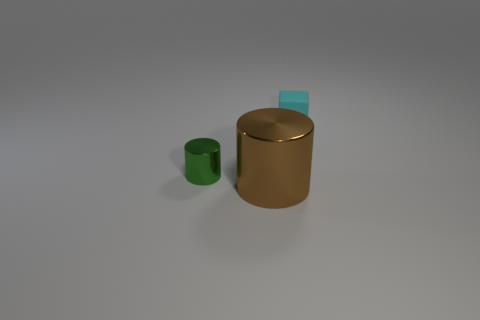Are there any small green things that have the same material as the big brown cylinder?
Keep it short and to the point. Yes. Are there any other things that have the same material as the tiny cyan cube?
Offer a very short reply. No. There is a object that is on the right side of the object that is in front of the green metal thing; what is its material?
Give a very brief answer. Rubber. There is a object behind the object left of the metallic thing in front of the green cylinder; what is its size?
Provide a short and direct response. Small. How many other things are there of the same shape as the brown thing?
Ensure brevity in your answer.  1. There is a object that is the same size as the cyan cube; what color is it?
Give a very brief answer. Green. Do the object that is behind the green cylinder and the tiny metallic object have the same size?
Your answer should be compact. Yes. Are there the same number of brown cylinders that are in front of the brown thing and tiny brown rubber objects?
Make the answer very short. Yes. How many objects are objects to the left of the tiny rubber block or brown cylinders?
Provide a short and direct response. 2. What shape is the object that is both behind the large brown metal cylinder and on the right side of the green shiny thing?
Your answer should be very brief. Cube. 